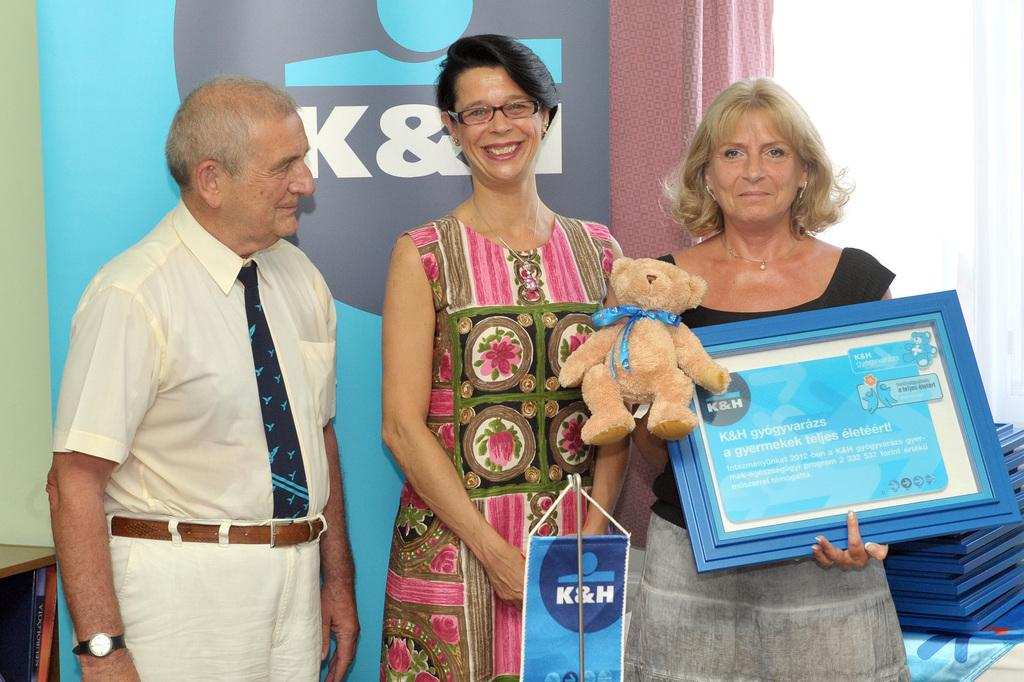How many people are present in the image? There are three people in the image: one man and two women. What is one of the women holding in the image? One woman is holding a frame and a teddy bear in the image. Can you describe the man's attire in the image? The man is wearing a tie and a watch in the image. What type of cream can be seen on the laborer's hands in the image? There is no laborer or cream present in the image. How many houses are visible in the image? There are no houses visible in the image. 